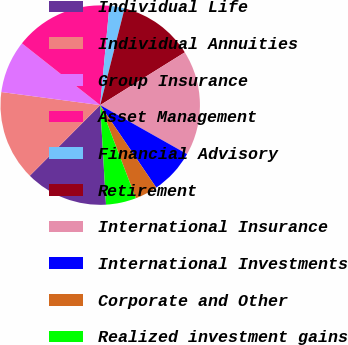<chart> <loc_0><loc_0><loc_500><loc_500><pie_chart><fcel>Individual Life<fcel>Individual Annuities<fcel>Group Insurance<fcel>Asset Management<fcel>Financial Advisory<fcel>Retirement<fcel>International Insurance<fcel>International Investments<fcel>Corporate and Other<fcel>Realized investment gains<nl><fcel>13.4%<fcel>14.62%<fcel>8.54%<fcel>15.84%<fcel>2.46%<fcel>12.19%<fcel>17.05%<fcel>7.33%<fcel>3.68%<fcel>4.89%<nl></chart> 